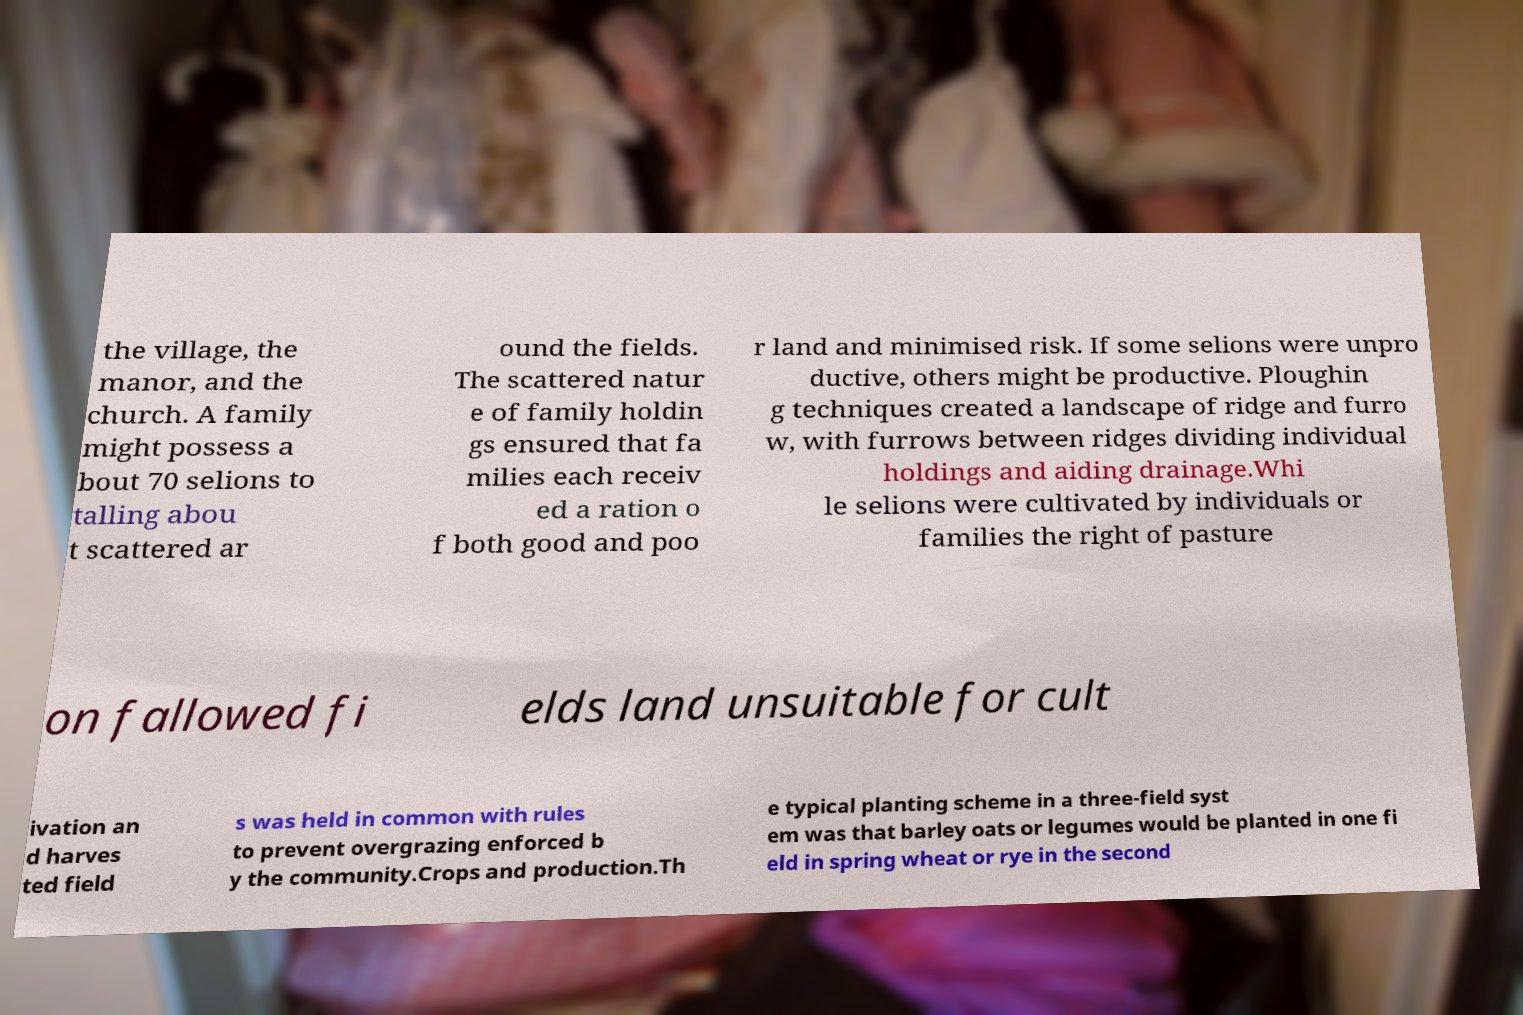For documentation purposes, I need the text within this image transcribed. Could you provide that? the village, the manor, and the church. A family might possess a bout 70 selions to talling abou t scattered ar ound the fields. The scattered natur e of family holdin gs ensured that fa milies each receiv ed a ration o f both good and poo r land and minimised risk. If some selions were unpro ductive, others might be productive. Ploughin g techniques created a landscape of ridge and furro w, with furrows between ridges dividing individual holdings and aiding drainage.Whi le selions were cultivated by individuals or families the right of pasture on fallowed fi elds land unsuitable for cult ivation an d harves ted field s was held in common with rules to prevent overgrazing enforced b y the community.Crops and production.Th e typical planting scheme in a three-field syst em was that barley oats or legumes would be planted in one fi eld in spring wheat or rye in the second 